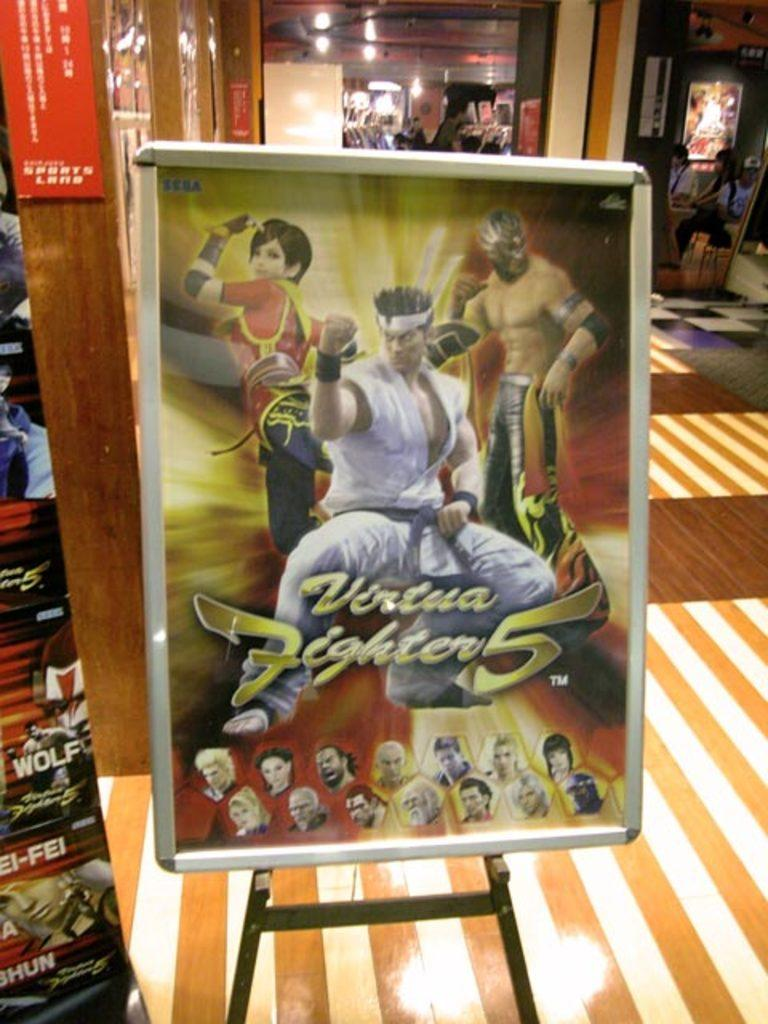<image>
Give a short and clear explanation of the subsequent image. Poster showing a screen of fighters for a video game and the words "Virtua Fighter 5". 